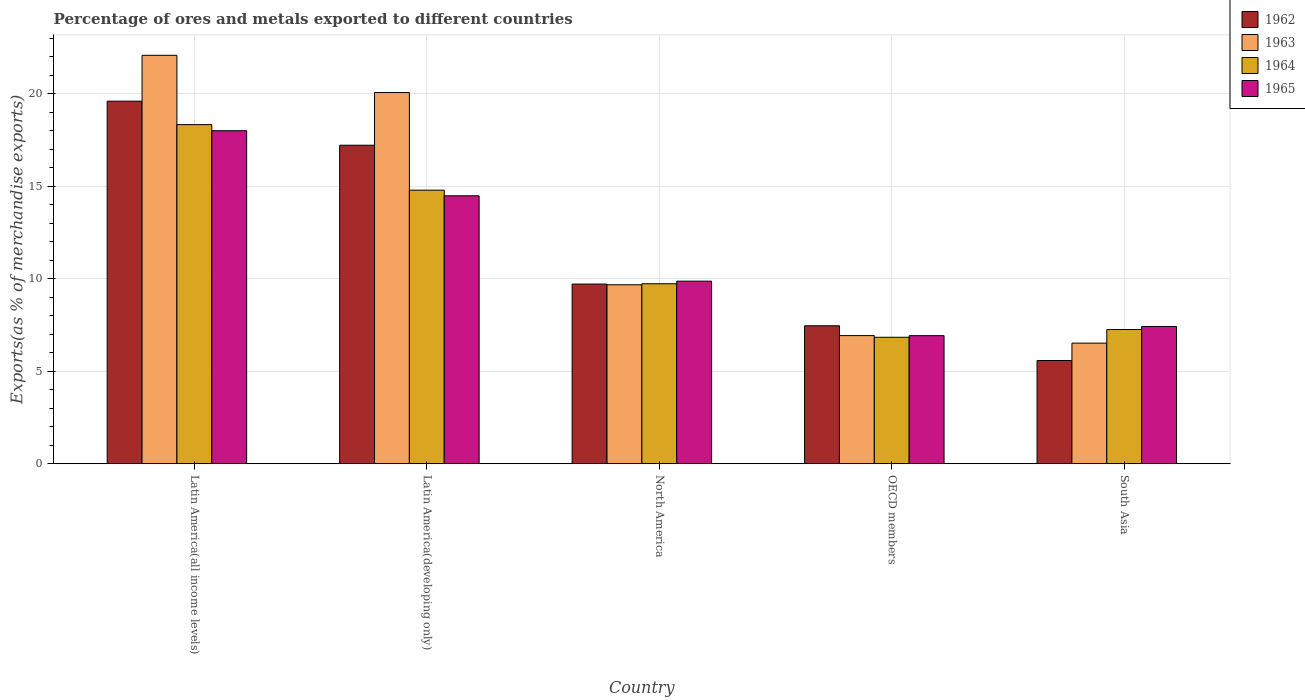How many groups of bars are there?
Provide a short and direct response. 5. Are the number of bars per tick equal to the number of legend labels?
Give a very brief answer. Yes. Are the number of bars on each tick of the X-axis equal?
Give a very brief answer. Yes. How many bars are there on the 5th tick from the right?
Your answer should be compact. 4. In how many cases, is the number of bars for a given country not equal to the number of legend labels?
Make the answer very short. 0. What is the percentage of exports to different countries in 1962 in North America?
Ensure brevity in your answer.  9.72. Across all countries, what is the maximum percentage of exports to different countries in 1963?
Offer a very short reply. 22.09. Across all countries, what is the minimum percentage of exports to different countries in 1964?
Make the answer very short. 6.84. In which country was the percentage of exports to different countries in 1964 maximum?
Your response must be concise. Latin America(all income levels). In which country was the percentage of exports to different countries in 1962 minimum?
Make the answer very short. South Asia. What is the total percentage of exports to different countries in 1965 in the graph?
Ensure brevity in your answer.  56.73. What is the difference between the percentage of exports to different countries in 1963 in North America and that in South Asia?
Make the answer very short. 3.16. What is the difference between the percentage of exports to different countries in 1965 in Latin America(developing only) and the percentage of exports to different countries in 1963 in South Asia?
Your answer should be very brief. 7.97. What is the average percentage of exports to different countries in 1963 per country?
Ensure brevity in your answer.  13.06. What is the difference between the percentage of exports to different countries of/in 1965 and percentage of exports to different countries of/in 1964 in South Asia?
Provide a succinct answer. 0.17. In how many countries, is the percentage of exports to different countries in 1964 greater than 2 %?
Your answer should be very brief. 5. What is the ratio of the percentage of exports to different countries in 1962 in Latin America(developing only) to that in OECD members?
Your answer should be very brief. 2.31. Is the percentage of exports to different countries in 1962 in Latin America(developing only) less than that in OECD members?
Your response must be concise. No. Is the difference between the percentage of exports to different countries in 1965 in Latin America(developing only) and South Asia greater than the difference between the percentage of exports to different countries in 1964 in Latin America(developing only) and South Asia?
Ensure brevity in your answer.  No. What is the difference between the highest and the second highest percentage of exports to different countries in 1964?
Make the answer very short. -8.61. What is the difference between the highest and the lowest percentage of exports to different countries in 1962?
Ensure brevity in your answer.  14.03. Is the sum of the percentage of exports to different countries in 1965 in Latin America(developing only) and OECD members greater than the maximum percentage of exports to different countries in 1962 across all countries?
Keep it short and to the point. Yes. What does the 2nd bar from the left in Latin America(all income levels) represents?
Your answer should be very brief. 1963. Is it the case that in every country, the sum of the percentage of exports to different countries in 1965 and percentage of exports to different countries in 1962 is greater than the percentage of exports to different countries in 1963?
Give a very brief answer. Yes. How many countries are there in the graph?
Your answer should be very brief. 5. Are the values on the major ticks of Y-axis written in scientific E-notation?
Offer a very short reply. No. What is the title of the graph?
Provide a short and direct response. Percentage of ores and metals exported to different countries. Does "1998" appear as one of the legend labels in the graph?
Give a very brief answer. No. What is the label or title of the X-axis?
Ensure brevity in your answer.  Country. What is the label or title of the Y-axis?
Provide a short and direct response. Exports(as % of merchandise exports). What is the Exports(as % of merchandise exports) in 1962 in Latin America(all income levels)?
Provide a short and direct response. 19.61. What is the Exports(as % of merchandise exports) in 1963 in Latin America(all income levels)?
Offer a very short reply. 22.09. What is the Exports(as % of merchandise exports) in 1964 in Latin America(all income levels)?
Keep it short and to the point. 18.34. What is the Exports(as % of merchandise exports) of 1965 in Latin America(all income levels)?
Ensure brevity in your answer.  18.01. What is the Exports(as % of merchandise exports) of 1962 in Latin America(developing only)?
Provide a short and direct response. 17.23. What is the Exports(as % of merchandise exports) of 1963 in Latin America(developing only)?
Give a very brief answer. 20.08. What is the Exports(as % of merchandise exports) in 1964 in Latin America(developing only)?
Offer a terse response. 14.8. What is the Exports(as % of merchandise exports) in 1965 in Latin America(developing only)?
Ensure brevity in your answer.  14.49. What is the Exports(as % of merchandise exports) in 1962 in North America?
Give a very brief answer. 9.72. What is the Exports(as % of merchandise exports) in 1963 in North America?
Offer a terse response. 9.68. What is the Exports(as % of merchandise exports) of 1964 in North America?
Your answer should be very brief. 9.73. What is the Exports(as % of merchandise exports) of 1965 in North America?
Keep it short and to the point. 9.87. What is the Exports(as % of merchandise exports) of 1962 in OECD members?
Your answer should be compact. 7.46. What is the Exports(as % of merchandise exports) in 1963 in OECD members?
Your response must be concise. 6.93. What is the Exports(as % of merchandise exports) in 1964 in OECD members?
Offer a very short reply. 6.84. What is the Exports(as % of merchandise exports) of 1965 in OECD members?
Make the answer very short. 6.93. What is the Exports(as % of merchandise exports) in 1962 in South Asia?
Keep it short and to the point. 5.58. What is the Exports(as % of merchandise exports) of 1963 in South Asia?
Make the answer very short. 6.52. What is the Exports(as % of merchandise exports) of 1964 in South Asia?
Provide a short and direct response. 7.26. What is the Exports(as % of merchandise exports) in 1965 in South Asia?
Make the answer very short. 7.42. Across all countries, what is the maximum Exports(as % of merchandise exports) of 1962?
Make the answer very short. 19.61. Across all countries, what is the maximum Exports(as % of merchandise exports) of 1963?
Keep it short and to the point. 22.09. Across all countries, what is the maximum Exports(as % of merchandise exports) in 1964?
Offer a very short reply. 18.34. Across all countries, what is the maximum Exports(as % of merchandise exports) in 1965?
Keep it short and to the point. 18.01. Across all countries, what is the minimum Exports(as % of merchandise exports) of 1962?
Ensure brevity in your answer.  5.58. Across all countries, what is the minimum Exports(as % of merchandise exports) in 1963?
Offer a very short reply. 6.52. Across all countries, what is the minimum Exports(as % of merchandise exports) in 1964?
Keep it short and to the point. 6.84. Across all countries, what is the minimum Exports(as % of merchandise exports) in 1965?
Your answer should be very brief. 6.93. What is the total Exports(as % of merchandise exports) of 1962 in the graph?
Ensure brevity in your answer.  59.6. What is the total Exports(as % of merchandise exports) in 1963 in the graph?
Provide a succinct answer. 65.3. What is the total Exports(as % of merchandise exports) in 1964 in the graph?
Provide a succinct answer. 56.97. What is the total Exports(as % of merchandise exports) in 1965 in the graph?
Keep it short and to the point. 56.73. What is the difference between the Exports(as % of merchandise exports) of 1962 in Latin America(all income levels) and that in Latin America(developing only)?
Keep it short and to the point. 2.38. What is the difference between the Exports(as % of merchandise exports) in 1963 in Latin America(all income levels) and that in Latin America(developing only)?
Your answer should be compact. 2.01. What is the difference between the Exports(as % of merchandise exports) of 1964 in Latin America(all income levels) and that in Latin America(developing only)?
Provide a succinct answer. 3.54. What is the difference between the Exports(as % of merchandise exports) in 1965 in Latin America(all income levels) and that in Latin America(developing only)?
Your response must be concise. 3.52. What is the difference between the Exports(as % of merchandise exports) in 1962 in Latin America(all income levels) and that in North America?
Ensure brevity in your answer.  9.89. What is the difference between the Exports(as % of merchandise exports) of 1963 in Latin America(all income levels) and that in North America?
Offer a very short reply. 12.41. What is the difference between the Exports(as % of merchandise exports) in 1964 in Latin America(all income levels) and that in North America?
Your answer should be compact. 8.61. What is the difference between the Exports(as % of merchandise exports) of 1965 in Latin America(all income levels) and that in North America?
Provide a short and direct response. 8.14. What is the difference between the Exports(as % of merchandise exports) in 1962 in Latin America(all income levels) and that in OECD members?
Provide a succinct answer. 12.15. What is the difference between the Exports(as % of merchandise exports) of 1963 in Latin America(all income levels) and that in OECD members?
Make the answer very short. 15.16. What is the difference between the Exports(as % of merchandise exports) in 1964 in Latin America(all income levels) and that in OECD members?
Keep it short and to the point. 11.5. What is the difference between the Exports(as % of merchandise exports) in 1965 in Latin America(all income levels) and that in OECD members?
Give a very brief answer. 11.09. What is the difference between the Exports(as % of merchandise exports) of 1962 in Latin America(all income levels) and that in South Asia?
Provide a short and direct response. 14.03. What is the difference between the Exports(as % of merchandise exports) in 1963 in Latin America(all income levels) and that in South Asia?
Your answer should be compact. 15.57. What is the difference between the Exports(as % of merchandise exports) of 1964 in Latin America(all income levels) and that in South Asia?
Ensure brevity in your answer.  11.08. What is the difference between the Exports(as % of merchandise exports) of 1965 in Latin America(all income levels) and that in South Asia?
Ensure brevity in your answer.  10.59. What is the difference between the Exports(as % of merchandise exports) of 1962 in Latin America(developing only) and that in North America?
Keep it short and to the point. 7.51. What is the difference between the Exports(as % of merchandise exports) in 1963 in Latin America(developing only) and that in North America?
Offer a terse response. 10.4. What is the difference between the Exports(as % of merchandise exports) of 1964 in Latin America(developing only) and that in North America?
Your answer should be compact. 5.06. What is the difference between the Exports(as % of merchandise exports) of 1965 in Latin America(developing only) and that in North America?
Your answer should be very brief. 4.62. What is the difference between the Exports(as % of merchandise exports) of 1962 in Latin America(developing only) and that in OECD members?
Make the answer very short. 9.76. What is the difference between the Exports(as % of merchandise exports) in 1963 in Latin America(developing only) and that in OECD members?
Offer a terse response. 13.15. What is the difference between the Exports(as % of merchandise exports) in 1964 in Latin America(developing only) and that in OECD members?
Keep it short and to the point. 7.96. What is the difference between the Exports(as % of merchandise exports) of 1965 in Latin America(developing only) and that in OECD members?
Your answer should be very brief. 7.57. What is the difference between the Exports(as % of merchandise exports) of 1962 in Latin America(developing only) and that in South Asia?
Offer a very short reply. 11.64. What is the difference between the Exports(as % of merchandise exports) of 1963 in Latin America(developing only) and that in South Asia?
Your answer should be very brief. 13.55. What is the difference between the Exports(as % of merchandise exports) of 1964 in Latin America(developing only) and that in South Asia?
Offer a very short reply. 7.54. What is the difference between the Exports(as % of merchandise exports) of 1965 in Latin America(developing only) and that in South Asia?
Provide a succinct answer. 7.07. What is the difference between the Exports(as % of merchandise exports) of 1962 in North America and that in OECD members?
Make the answer very short. 2.26. What is the difference between the Exports(as % of merchandise exports) in 1963 in North America and that in OECD members?
Your answer should be compact. 2.75. What is the difference between the Exports(as % of merchandise exports) in 1964 in North America and that in OECD members?
Your answer should be very brief. 2.9. What is the difference between the Exports(as % of merchandise exports) of 1965 in North America and that in OECD members?
Ensure brevity in your answer.  2.95. What is the difference between the Exports(as % of merchandise exports) in 1962 in North America and that in South Asia?
Make the answer very short. 4.13. What is the difference between the Exports(as % of merchandise exports) in 1963 in North America and that in South Asia?
Your answer should be very brief. 3.16. What is the difference between the Exports(as % of merchandise exports) in 1964 in North America and that in South Asia?
Ensure brevity in your answer.  2.48. What is the difference between the Exports(as % of merchandise exports) of 1965 in North America and that in South Asia?
Make the answer very short. 2.45. What is the difference between the Exports(as % of merchandise exports) in 1962 in OECD members and that in South Asia?
Provide a succinct answer. 1.88. What is the difference between the Exports(as % of merchandise exports) in 1963 in OECD members and that in South Asia?
Give a very brief answer. 0.41. What is the difference between the Exports(as % of merchandise exports) of 1964 in OECD members and that in South Asia?
Your answer should be very brief. -0.42. What is the difference between the Exports(as % of merchandise exports) of 1965 in OECD members and that in South Asia?
Provide a succinct answer. -0.5. What is the difference between the Exports(as % of merchandise exports) in 1962 in Latin America(all income levels) and the Exports(as % of merchandise exports) in 1963 in Latin America(developing only)?
Offer a terse response. -0.47. What is the difference between the Exports(as % of merchandise exports) in 1962 in Latin America(all income levels) and the Exports(as % of merchandise exports) in 1964 in Latin America(developing only)?
Provide a succinct answer. 4.81. What is the difference between the Exports(as % of merchandise exports) in 1962 in Latin America(all income levels) and the Exports(as % of merchandise exports) in 1965 in Latin America(developing only)?
Ensure brevity in your answer.  5.12. What is the difference between the Exports(as % of merchandise exports) in 1963 in Latin America(all income levels) and the Exports(as % of merchandise exports) in 1964 in Latin America(developing only)?
Offer a very short reply. 7.29. What is the difference between the Exports(as % of merchandise exports) in 1963 in Latin America(all income levels) and the Exports(as % of merchandise exports) in 1965 in Latin America(developing only)?
Your answer should be compact. 7.6. What is the difference between the Exports(as % of merchandise exports) in 1964 in Latin America(all income levels) and the Exports(as % of merchandise exports) in 1965 in Latin America(developing only)?
Your answer should be compact. 3.85. What is the difference between the Exports(as % of merchandise exports) in 1962 in Latin America(all income levels) and the Exports(as % of merchandise exports) in 1963 in North America?
Your response must be concise. 9.93. What is the difference between the Exports(as % of merchandise exports) of 1962 in Latin America(all income levels) and the Exports(as % of merchandise exports) of 1964 in North America?
Your answer should be compact. 9.88. What is the difference between the Exports(as % of merchandise exports) in 1962 in Latin America(all income levels) and the Exports(as % of merchandise exports) in 1965 in North America?
Ensure brevity in your answer.  9.73. What is the difference between the Exports(as % of merchandise exports) in 1963 in Latin America(all income levels) and the Exports(as % of merchandise exports) in 1964 in North America?
Your answer should be compact. 12.36. What is the difference between the Exports(as % of merchandise exports) of 1963 in Latin America(all income levels) and the Exports(as % of merchandise exports) of 1965 in North America?
Provide a short and direct response. 12.22. What is the difference between the Exports(as % of merchandise exports) of 1964 in Latin America(all income levels) and the Exports(as % of merchandise exports) of 1965 in North America?
Ensure brevity in your answer.  8.47. What is the difference between the Exports(as % of merchandise exports) in 1962 in Latin America(all income levels) and the Exports(as % of merchandise exports) in 1963 in OECD members?
Your answer should be very brief. 12.68. What is the difference between the Exports(as % of merchandise exports) of 1962 in Latin America(all income levels) and the Exports(as % of merchandise exports) of 1964 in OECD members?
Keep it short and to the point. 12.77. What is the difference between the Exports(as % of merchandise exports) of 1962 in Latin America(all income levels) and the Exports(as % of merchandise exports) of 1965 in OECD members?
Give a very brief answer. 12.68. What is the difference between the Exports(as % of merchandise exports) in 1963 in Latin America(all income levels) and the Exports(as % of merchandise exports) in 1964 in OECD members?
Offer a terse response. 15.25. What is the difference between the Exports(as % of merchandise exports) in 1963 in Latin America(all income levels) and the Exports(as % of merchandise exports) in 1965 in OECD members?
Your answer should be very brief. 15.16. What is the difference between the Exports(as % of merchandise exports) in 1964 in Latin America(all income levels) and the Exports(as % of merchandise exports) in 1965 in OECD members?
Give a very brief answer. 11.41. What is the difference between the Exports(as % of merchandise exports) of 1962 in Latin America(all income levels) and the Exports(as % of merchandise exports) of 1963 in South Asia?
Make the answer very short. 13.09. What is the difference between the Exports(as % of merchandise exports) of 1962 in Latin America(all income levels) and the Exports(as % of merchandise exports) of 1964 in South Asia?
Give a very brief answer. 12.35. What is the difference between the Exports(as % of merchandise exports) of 1962 in Latin America(all income levels) and the Exports(as % of merchandise exports) of 1965 in South Asia?
Offer a terse response. 12.18. What is the difference between the Exports(as % of merchandise exports) in 1963 in Latin America(all income levels) and the Exports(as % of merchandise exports) in 1964 in South Asia?
Your answer should be very brief. 14.83. What is the difference between the Exports(as % of merchandise exports) of 1963 in Latin America(all income levels) and the Exports(as % of merchandise exports) of 1965 in South Asia?
Provide a succinct answer. 14.67. What is the difference between the Exports(as % of merchandise exports) in 1964 in Latin America(all income levels) and the Exports(as % of merchandise exports) in 1965 in South Asia?
Ensure brevity in your answer.  10.92. What is the difference between the Exports(as % of merchandise exports) of 1962 in Latin America(developing only) and the Exports(as % of merchandise exports) of 1963 in North America?
Make the answer very short. 7.55. What is the difference between the Exports(as % of merchandise exports) of 1962 in Latin America(developing only) and the Exports(as % of merchandise exports) of 1964 in North America?
Your response must be concise. 7.49. What is the difference between the Exports(as % of merchandise exports) in 1962 in Latin America(developing only) and the Exports(as % of merchandise exports) in 1965 in North America?
Your answer should be very brief. 7.35. What is the difference between the Exports(as % of merchandise exports) of 1963 in Latin America(developing only) and the Exports(as % of merchandise exports) of 1964 in North America?
Make the answer very short. 10.34. What is the difference between the Exports(as % of merchandise exports) of 1963 in Latin America(developing only) and the Exports(as % of merchandise exports) of 1965 in North America?
Offer a terse response. 10.2. What is the difference between the Exports(as % of merchandise exports) in 1964 in Latin America(developing only) and the Exports(as % of merchandise exports) in 1965 in North America?
Keep it short and to the point. 4.92. What is the difference between the Exports(as % of merchandise exports) of 1962 in Latin America(developing only) and the Exports(as % of merchandise exports) of 1963 in OECD members?
Offer a very short reply. 10.3. What is the difference between the Exports(as % of merchandise exports) of 1962 in Latin America(developing only) and the Exports(as % of merchandise exports) of 1964 in OECD members?
Give a very brief answer. 10.39. What is the difference between the Exports(as % of merchandise exports) in 1962 in Latin America(developing only) and the Exports(as % of merchandise exports) in 1965 in OECD members?
Make the answer very short. 10.3. What is the difference between the Exports(as % of merchandise exports) of 1963 in Latin America(developing only) and the Exports(as % of merchandise exports) of 1964 in OECD members?
Your answer should be compact. 13.24. What is the difference between the Exports(as % of merchandise exports) of 1963 in Latin America(developing only) and the Exports(as % of merchandise exports) of 1965 in OECD members?
Provide a succinct answer. 13.15. What is the difference between the Exports(as % of merchandise exports) in 1964 in Latin America(developing only) and the Exports(as % of merchandise exports) in 1965 in OECD members?
Offer a very short reply. 7.87. What is the difference between the Exports(as % of merchandise exports) in 1962 in Latin America(developing only) and the Exports(as % of merchandise exports) in 1963 in South Asia?
Offer a terse response. 10.7. What is the difference between the Exports(as % of merchandise exports) in 1962 in Latin America(developing only) and the Exports(as % of merchandise exports) in 1964 in South Asia?
Provide a succinct answer. 9.97. What is the difference between the Exports(as % of merchandise exports) in 1962 in Latin America(developing only) and the Exports(as % of merchandise exports) in 1965 in South Asia?
Your answer should be very brief. 9.8. What is the difference between the Exports(as % of merchandise exports) of 1963 in Latin America(developing only) and the Exports(as % of merchandise exports) of 1964 in South Asia?
Make the answer very short. 12.82. What is the difference between the Exports(as % of merchandise exports) of 1963 in Latin America(developing only) and the Exports(as % of merchandise exports) of 1965 in South Asia?
Provide a short and direct response. 12.65. What is the difference between the Exports(as % of merchandise exports) of 1964 in Latin America(developing only) and the Exports(as % of merchandise exports) of 1965 in South Asia?
Ensure brevity in your answer.  7.37. What is the difference between the Exports(as % of merchandise exports) in 1962 in North America and the Exports(as % of merchandise exports) in 1963 in OECD members?
Give a very brief answer. 2.79. What is the difference between the Exports(as % of merchandise exports) in 1962 in North America and the Exports(as % of merchandise exports) in 1964 in OECD members?
Make the answer very short. 2.88. What is the difference between the Exports(as % of merchandise exports) in 1962 in North America and the Exports(as % of merchandise exports) in 1965 in OECD members?
Keep it short and to the point. 2.79. What is the difference between the Exports(as % of merchandise exports) of 1963 in North America and the Exports(as % of merchandise exports) of 1964 in OECD members?
Provide a short and direct response. 2.84. What is the difference between the Exports(as % of merchandise exports) in 1963 in North America and the Exports(as % of merchandise exports) in 1965 in OECD members?
Provide a succinct answer. 2.75. What is the difference between the Exports(as % of merchandise exports) of 1964 in North America and the Exports(as % of merchandise exports) of 1965 in OECD members?
Give a very brief answer. 2.81. What is the difference between the Exports(as % of merchandise exports) in 1962 in North America and the Exports(as % of merchandise exports) in 1963 in South Asia?
Your answer should be compact. 3.19. What is the difference between the Exports(as % of merchandise exports) of 1962 in North America and the Exports(as % of merchandise exports) of 1964 in South Asia?
Offer a very short reply. 2.46. What is the difference between the Exports(as % of merchandise exports) in 1962 in North America and the Exports(as % of merchandise exports) in 1965 in South Asia?
Offer a very short reply. 2.29. What is the difference between the Exports(as % of merchandise exports) in 1963 in North America and the Exports(as % of merchandise exports) in 1964 in South Asia?
Your response must be concise. 2.42. What is the difference between the Exports(as % of merchandise exports) in 1963 in North America and the Exports(as % of merchandise exports) in 1965 in South Asia?
Your answer should be compact. 2.25. What is the difference between the Exports(as % of merchandise exports) in 1964 in North America and the Exports(as % of merchandise exports) in 1965 in South Asia?
Make the answer very short. 2.31. What is the difference between the Exports(as % of merchandise exports) in 1962 in OECD members and the Exports(as % of merchandise exports) in 1963 in South Asia?
Ensure brevity in your answer.  0.94. What is the difference between the Exports(as % of merchandise exports) of 1962 in OECD members and the Exports(as % of merchandise exports) of 1964 in South Asia?
Your answer should be very brief. 0.2. What is the difference between the Exports(as % of merchandise exports) in 1962 in OECD members and the Exports(as % of merchandise exports) in 1965 in South Asia?
Your response must be concise. 0.04. What is the difference between the Exports(as % of merchandise exports) of 1963 in OECD members and the Exports(as % of merchandise exports) of 1964 in South Asia?
Your answer should be compact. -0.33. What is the difference between the Exports(as % of merchandise exports) in 1963 in OECD members and the Exports(as % of merchandise exports) in 1965 in South Asia?
Ensure brevity in your answer.  -0.49. What is the difference between the Exports(as % of merchandise exports) in 1964 in OECD members and the Exports(as % of merchandise exports) in 1965 in South Asia?
Make the answer very short. -0.59. What is the average Exports(as % of merchandise exports) in 1962 per country?
Provide a succinct answer. 11.92. What is the average Exports(as % of merchandise exports) of 1963 per country?
Your answer should be compact. 13.06. What is the average Exports(as % of merchandise exports) of 1964 per country?
Ensure brevity in your answer.  11.39. What is the average Exports(as % of merchandise exports) in 1965 per country?
Your answer should be very brief. 11.35. What is the difference between the Exports(as % of merchandise exports) in 1962 and Exports(as % of merchandise exports) in 1963 in Latin America(all income levels)?
Offer a very short reply. -2.48. What is the difference between the Exports(as % of merchandise exports) in 1962 and Exports(as % of merchandise exports) in 1964 in Latin America(all income levels)?
Provide a succinct answer. 1.27. What is the difference between the Exports(as % of merchandise exports) of 1962 and Exports(as % of merchandise exports) of 1965 in Latin America(all income levels)?
Make the answer very short. 1.6. What is the difference between the Exports(as % of merchandise exports) in 1963 and Exports(as % of merchandise exports) in 1964 in Latin America(all income levels)?
Your answer should be very brief. 3.75. What is the difference between the Exports(as % of merchandise exports) in 1963 and Exports(as % of merchandise exports) in 1965 in Latin America(all income levels)?
Your response must be concise. 4.08. What is the difference between the Exports(as % of merchandise exports) of 1964 and Exports(as % of merchandise exports) of 1965 in Latin America(all income levels)?
Give a very brief answer. 0.33. What is the difference between the Exports(as % of merchandise exports) in 1962 and Exports(as % of merchandise exports) in 1963 in Latin America(developing only)?
Keep it short and to the point. -2.85. What is the difference between the Exports(as % of merchandise exports) in 1962 and Exports(as % of merchandise exports) in 1964 in Latin America(developing only)?
Provide a succinct answer. 2.43. What is the difference between the Exports(as % of merchandise exports) in 1962 and Exports(as % of merchandise exports) in 1965 in Latin America(developing only)?
Keep it short and to the point. 2.73. What is the difference between the Exports(as % of merchandise exports) in 1963 and Exports(as % of merchandise exports) in 1964 in Latin America(developing only)?
Your answer should be compact. 5.28. What is the difference between the Exports(as % of merchandise exports) of 1963 and Exports(as % of merchandise exports) of 1965 in Latin America(developing only)?
Give a very brief answer. 5.58. What is the difference between the Exports(as % of merchandise exports) of 1964 and Exports(as % of merchandise exports) of 1965 in Latin America(developing only)?
Make the answer very short. 0.3. What is the difference between the Exports(as % of merchandise exports) of 1962 and Exports(as % of merchandise exports) of 1963 in North America?
Ensure brevity in your answer.  0.04. What is the difference between the Exports(as % of merchandise exports) in 1962 and Exports(as % of merchandise exports) in 1964 in North America?
Ensure brevity in your answer.  -0.02. What is the difference between the Exports(as % of merchandise exports) in 1962 and Exports(as % of merchandise exports) in 1965 in North America?
Keep it short and to the point. -0.16. What is the difference between the Exports(as % of merchandise exports) of 1963 and Exports(as % of merchandise exports) of 1964 in North America?
Offer a very short reply. -0.06. What is the difference between the Exports(as % of merchandise exports) of 1963 and Exports(as % of merchandise exports) of 1965 in North America?
Offer a terse response. -0.2. What is the difference between the Exports(as % of merchandise exports) in 1964 and Exports(as % of merchandise exports) in 1965 in North America?
Your answer should be very brief. -0.14. What is the difference between the Exports(as % of merchandise exports) of 1962 and Exports(as % of merchandise exports) of 1963 in OECD members?
Provide a short and direct response. 0.53. What is the difference between the Exports(as % of merchandise exports) in 1962 and Exports(as % of merchandise exports) in 1964 in OECD members?
Your response must be concise. 0.62. What is the difference between the Exports(as % of merchandise exports) of 1962 and Exports(as % of merchandise exports) of 1965 in OECD members?
Ensure brevity in your answer.  0.54. What is the difference between the Exports(as % of merchandise exports) of 1963 and Exports(as % of merchandise exports) of 1964 in OECD members?
Your answer should be very brief. 0.09. What is the difference between the Exports(as % of merchandise exports) of 1963 and Exports(as % of merchandise exports) of 1965 in OECD members?
Make the answer very short. 0. What is the difference between the Exports(as % of merchandise exports) in 1964 and Exports(as % of merchandise exports) in 1965 in OECD members?
Your answer should be very brief. -0.09. What is the difference between the Exports(as % of merchandise exports) of 1962 and Exports(as % of merchandise exports) of 1963 in South Asia?
Your answer should be compact. -0.94. What is the difference between the Exports(as % of merchandise exports) of 1962 and Exports(as % of merchandise exports) of 1964 in South Asia?
Offer a terse response. -1.68. What is the difference between the Exports(as % of merchandise exports) of 1962 and Exports(as % of merchandise exports) of 1965 in South Asia?
Give a very brief answer. -1.84. What is the difference between the Exports(as % of merchandise exports) in 1963 and Exports(as % of merchandise exports) in 1964 in South Asia?
Your response must be concise. -0.74. What is the difference between the Exports(as % of merchandise exports) of 1963 and Exports(as % of merchandise exports) of 1965 in South Asia?
Your answer should be very brief. -0.9. What is the difference between the Exports(as % of merchandise exports) in 1964 and Exports(as % of merchandise exports) in 1965 in South Asia?
Provide a succinct answer. -0.17. What is the ratio of the Exports(as % of merchandise exports) of 1962 in Latin America(all income levels) to that in Latin America(developing only)?
Your answer should be compact. 1.14. What is the ratio of the Exports(as % of merchandise exports) in 1963 in Latin America(all income levels) to that in Latin America(developing only)?
Provide a succinct answer. 1.1. What is the ratio of the Exports(as % of merchandise exports) in 1964 in Latin America(all income levels) to that in Latin America(developing only)?
Ensure brevity in your answer.  1.24. What is the ratio of the Exports(as % of merchandise exports) of 1965 in Latin America(all income levels) to that in Latin America(developing only)?
Your response must be concise. 1.24. What is the ratio of the Exports(as % of merchandise exports) in 1962 in Latin America(all income levels) to that in North America?
Ensure brevity in your answer.  2.02. What is the ratio of the Exports(as % of merchandise exports) of 1963 in Latin America(all income levels) to that in North America?
Offer a terse response. 2.28. What is the ratio of the Exports(as % of merchandise exports) of 1964 in Latin America(all income levels) to that in North America?
Offer a terse response. 1.88. What is the ratio of the Exports(as % of merchandise exports) of 1965 in Latin America(all income levels) to that in North America?
Ensure brevity in your answer.  1.82. What is the ratio of the Exports(as % of merchandise exports) of 1962 in Latin America(all income levels) to that in OECD members?
Provide a short and direct response. 2.63. What is the ratio of the Exports(as % of merchandise exports) of 1963 in Latin America(all income levels) to that in OECD members?
Provide a short and direct response. 3.19. What is the ratio of the Exports(as % of merchandise exports) of 1964 in Latin America(all income levels) to that in OECD members?
Your answer should be compact. 2.68. What is the ratio of the Exports(as % of merchandise exports) of 1965 in Latin America(all income levels) to that in OECD members?
Your answer should be compact. 2.6. What is the ratio of the Exports(as % of merchandise exports) of 1962 in Latin America(all income levels) to that in South Asia?
Make the answer very short. 3.51. What is the ratio of the Exports(as % of merchandise exports) of 1963 in Latin America(all income levels) to that in South Asia?
Ensure brevity in your answer.  3.39. What is the ratio of the Exports(as % of merchandise exports) of 1964 in Latin America(all income levels) to that in South Asia?
Your answer should be compact. 2.53. What is the ratio of the Exports(as % of merchandise exports) in 1965 in Latin America(all income levels) to that in South Asia?
Provide a short and direct response. 2.43. What is the ratio of the Exports(as % of merchandise exports) in 1962 in Latin America(developing only) to that in North America?
Provide a succinct answer. 1.77. What is the ratio of the Exports(as % of merchandise exports) in 1963 in Latin America(developing only) to that in North America?
Your answer should be compact. 2.07. What is the ratio of the Exports(as % of merchandise exports) of 1964 in Latin America(developing only) to that in North America?
Your answer should be compact. 1.52. What is the ratio of the Exports(as % of merchandise exports) of 1965 in Latin America(developing only) to that in North America?
Offer a terse response. 1.47. What is the ratio of the Exports(as % of merchandise exports) of 1962 in Latin America(developing only) to that in OECD members?
Provide a succinct answer. 2.31. What is the ratio of the Exports(as % of merchandise exports) of 1963 in Latin America(developing only) to that in OECD members?
Your answer should be compact. 2.9. What is the ratio of the Exports(as % of merchandise exports) in 1964 in Latin America(developing only) to that in OECD members?
Provide a short and direct response. 2.16. What is the ratio of the Exports(as % of merchandise exports) in 1965 in Latin America(developing only) to that in OECD members?
Provide a succinct answer. 2.09. What is the ratio of the Exports(as % of merchandise exports) of 1962 in Latin America(developing only) to that in South Asia?
Ensure brevity in your answer.  3.08. What is the ratio of the Exports(as % of merchandise exports) of 1963 in Latin America(developing only) to that in South Asia?
Offer a very short reply. 3.08. What is the ratio of the Exports(as % of merchandise exports) of 1964 in Latin America(developing only) to that in South Asia?
Provide a short and direct response. 2.04. What is the ratio of the Exports(as % of merchandise exports) of 1965 in Latin America(developing only) to that in South Asia?
Your answer should be very brief. 1.95. What is the ratio of the Exports(as % of merchandise exports) of 1962 in North America to that in OECD members?
Offer a terse response. 1.3. What is the ratio of the Exports(as % of merchandise exports) in 1963 in North America to that in OECD members?
Your answer should be compact. 1.4. What is the ratio of the Exports(as % of merchandise exports) of 1964 in North America to that in OECD members?
Keep it short and to the point. 1.42. What is the ratio of the Exports(as % of merchandise exports) of 1965 in North America to that in OECD members?
Keep it short and to the point. 1.43. What is the ratio of the Exports(as % of merchandise exports) of 1962 in North America to that in South Asia?
Offer a terse response. 1.74. What is the ratio of the Exports(as % of merchandise exports) of 1963 in North America to that in South Asia?
Your response must be concise. 1.48. What is the ratio of the Exports(as % of merchandise exports) in 1964 in North America to that in South Asia?
Your answer should be very brief. 1.34. What is the ratio of the Exports(as % of merchandise exports) in 1965 in North America to that in South Asia?
Ensure brevity in your answer.  1.33. What is the ratio of the Exports(as % of merchandise exports) in 1962 in OECD members to that in South Asia?
Offer a terse response. 1.34. What is the ratio of the Exports(as % of merchandise exports) in 1963 in OECD members to that in South Asia?
Your response must be concise. 1.06. What is the ratio of the Exports(as % of merchandise exports) of 1964 in OECD members to that in South Asia?
Your response must be concise. 0.94. What is the ratio of the Exports(as % of merchandise exports) in 1965 in OECD members to that in South Asia?
Keep it short and to the point. 0.93. What is the difference between the highest and the second highest Exports(as % of merchandise exports) in 1962?
Provide a short and direct response. 2.38. What is the difference between the highest and the second highest Exports(as % of merchandise exports) of 1963?
Keep it short and to the point. 2.01. What is the difference between the highest and the second highest Exports(as % of merchandise exports) of 1964?
Your response must be concise. 3.54. What is the difference between the highest and the second highest Exports(as % of merchandise exports) in 1965?
Keep it short and to the point. 3.52. What is the difference between the highest and the lowest Exports(as % of merchandise exports) of 1962?
Your answer should be very brief. 14.03. What is the difference between the highest and the lowest Exports(as % of merchandise exports) in 1963?
Ensure brevity in your answer.  15.57. What is the difference between the highest and the lowest Exports(as % of merchandise exports) in 1964?
Make the answer very short. 11.5. What is the difference between the highest and the lowest Exports(as % of merchandise exports) of 1965?
Make the answer very short. 11.09. 